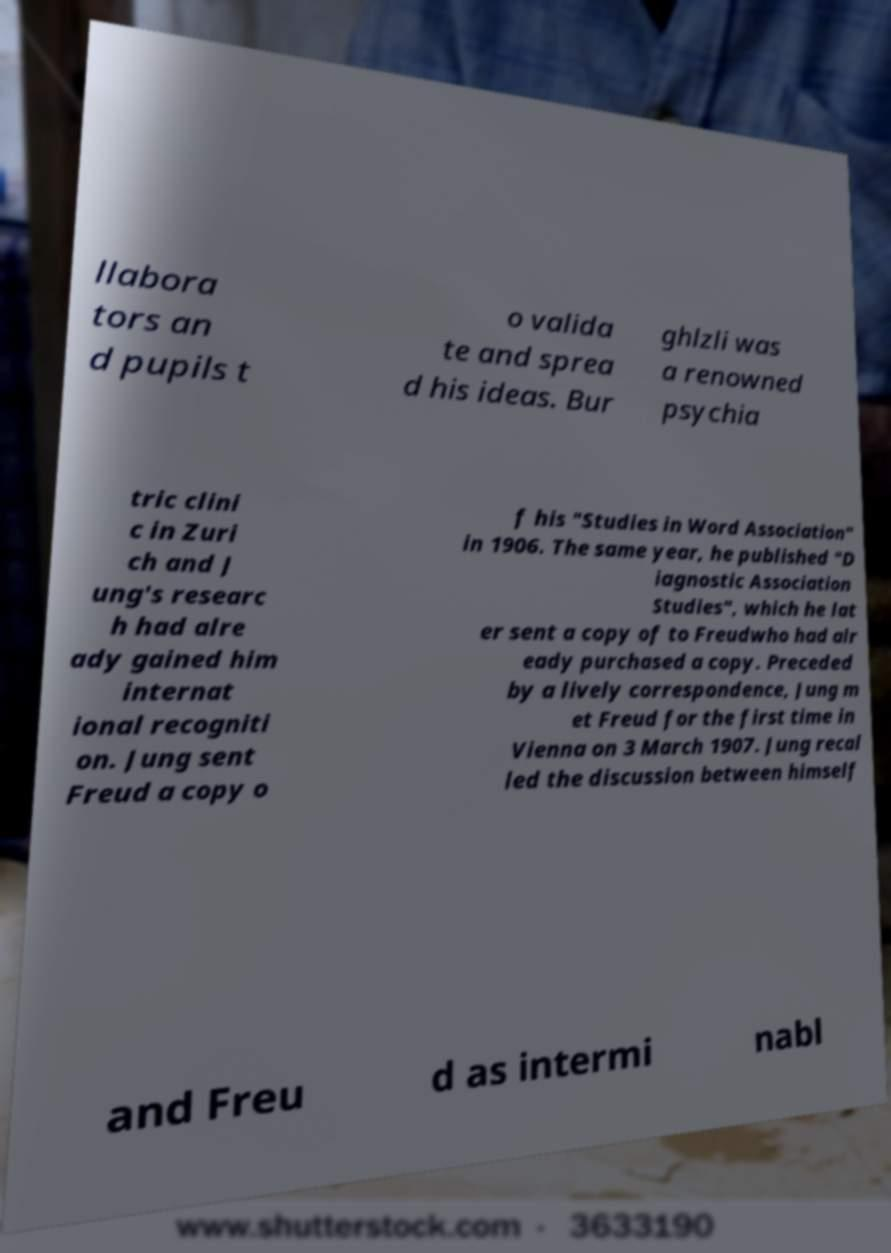I need the written content from this picture converted into text. Can you do that? llabora tors an d pupils t o valida te and sprea d his ideas. Bur ghlzli was a renowned psychia tric clini c in Zuri ch and J ung's researc h had alre ady gained him internat ional recogniti on. Jung sent Freud a copy o f his "Studies in Word Association" in 1906. The same year, he published "D iagnostic Association Studies", which he lat er sent a copy of to Freudwho had alr eady purchased a copy. Preceded by a lively correspondence, Jung m et Freud for the first time in Vienna on 3 March 1907. Jung recal led the discussion between himself and Freu d as intermi nabl 